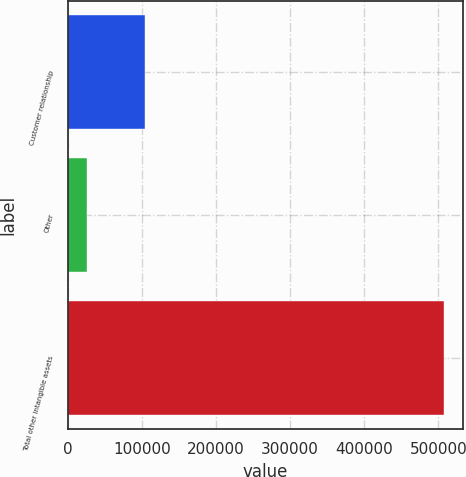Convert chart to OTSL. <chart><loc_0><loc_0><loc_500><loc_500><bar_chart><fcel>Customer relationship<fcel>Other<fcel>Total other intangible assets<nl><fcel>104574<fcel>26465<fcel>507885<nl></chart> 